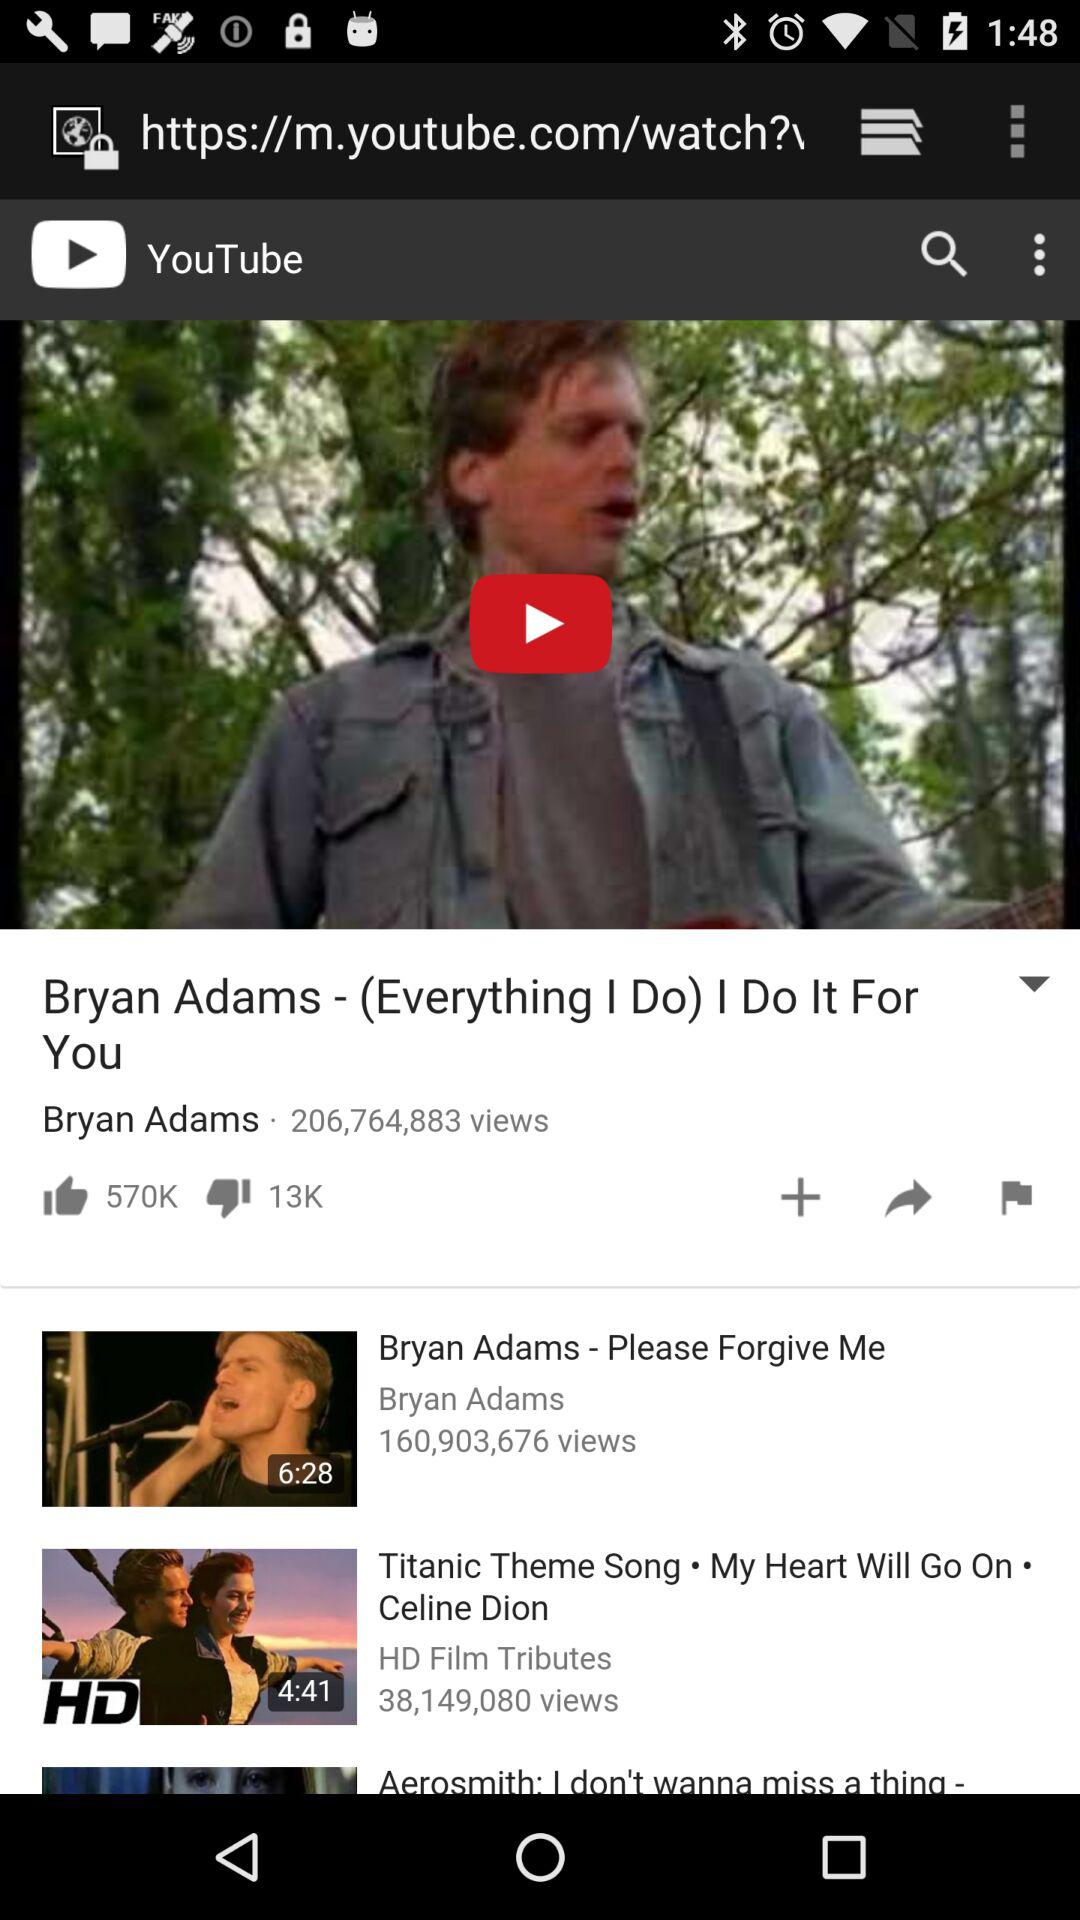How many people have liked the video? There are 570,000 people who have liked the video. 